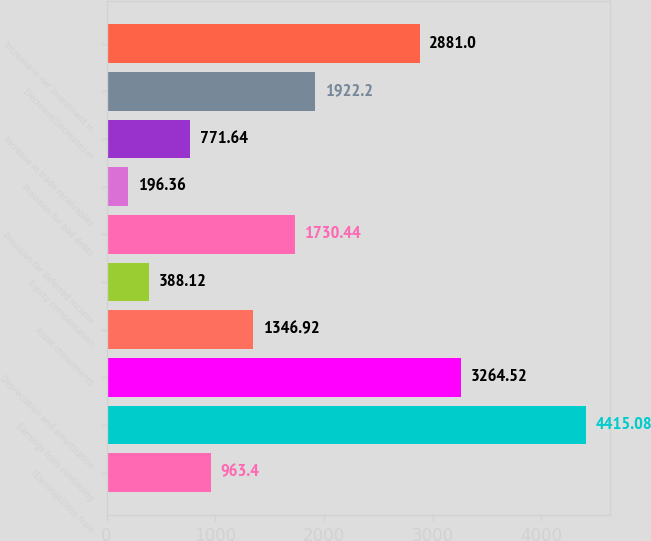<chart> <loc_0><loc_0><loc_500><loc_500><bar_chart><fcel>(Earnings)/loss from<fcel>Earnings from continuing<fcel>Depreciation and amortization<fcel>Asset impairments<fcel>Equity compensation<fcel>Provision for deferred income<fcel>Provision for bad debts<fcel>Increase in trade receivables<fcel>Decrease/(increase) in<fcel>Increase in net investment in<nl><fcel>963.4<fcel>4415.08<fcel>3264.52<fcel>1346.92<fcel>388.12<fcel>1730.44<fcel>196.36<fcel>771.64<fcel>1922.2<fcel>2881<nl></chart> 